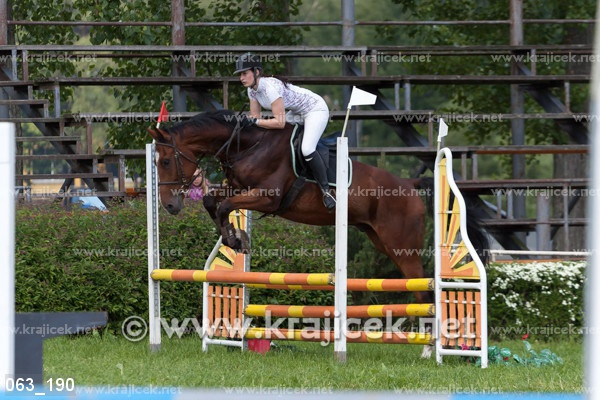Describe the objects in this image and their specific colors. I can see horse in gray, black, maroon, and white tones and people in gray, lavender, black, and darkgray tones in this image. 